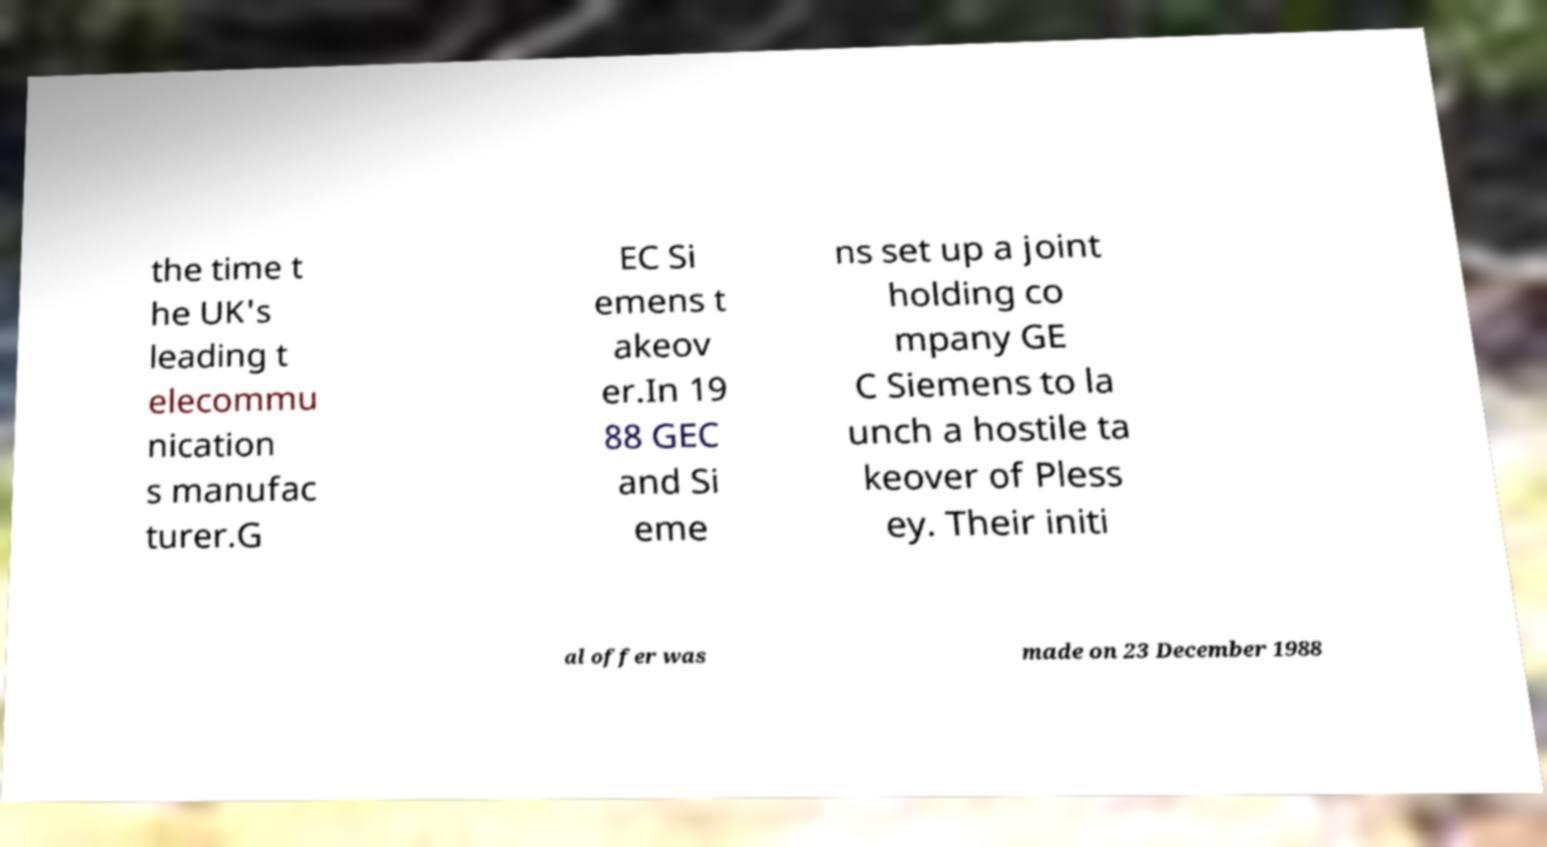Please identify and transcribe the text found in this image. the time t he UK's leading t elecommu nication s manufac turer.G EC Si emens t akeov er.In 19 88 GEC and Si eme ns set up a joint holding co mpany GE C Siemens to la unch a hostile ta keover of Pless ey. Their initi al offer was made on 23 December 1988 